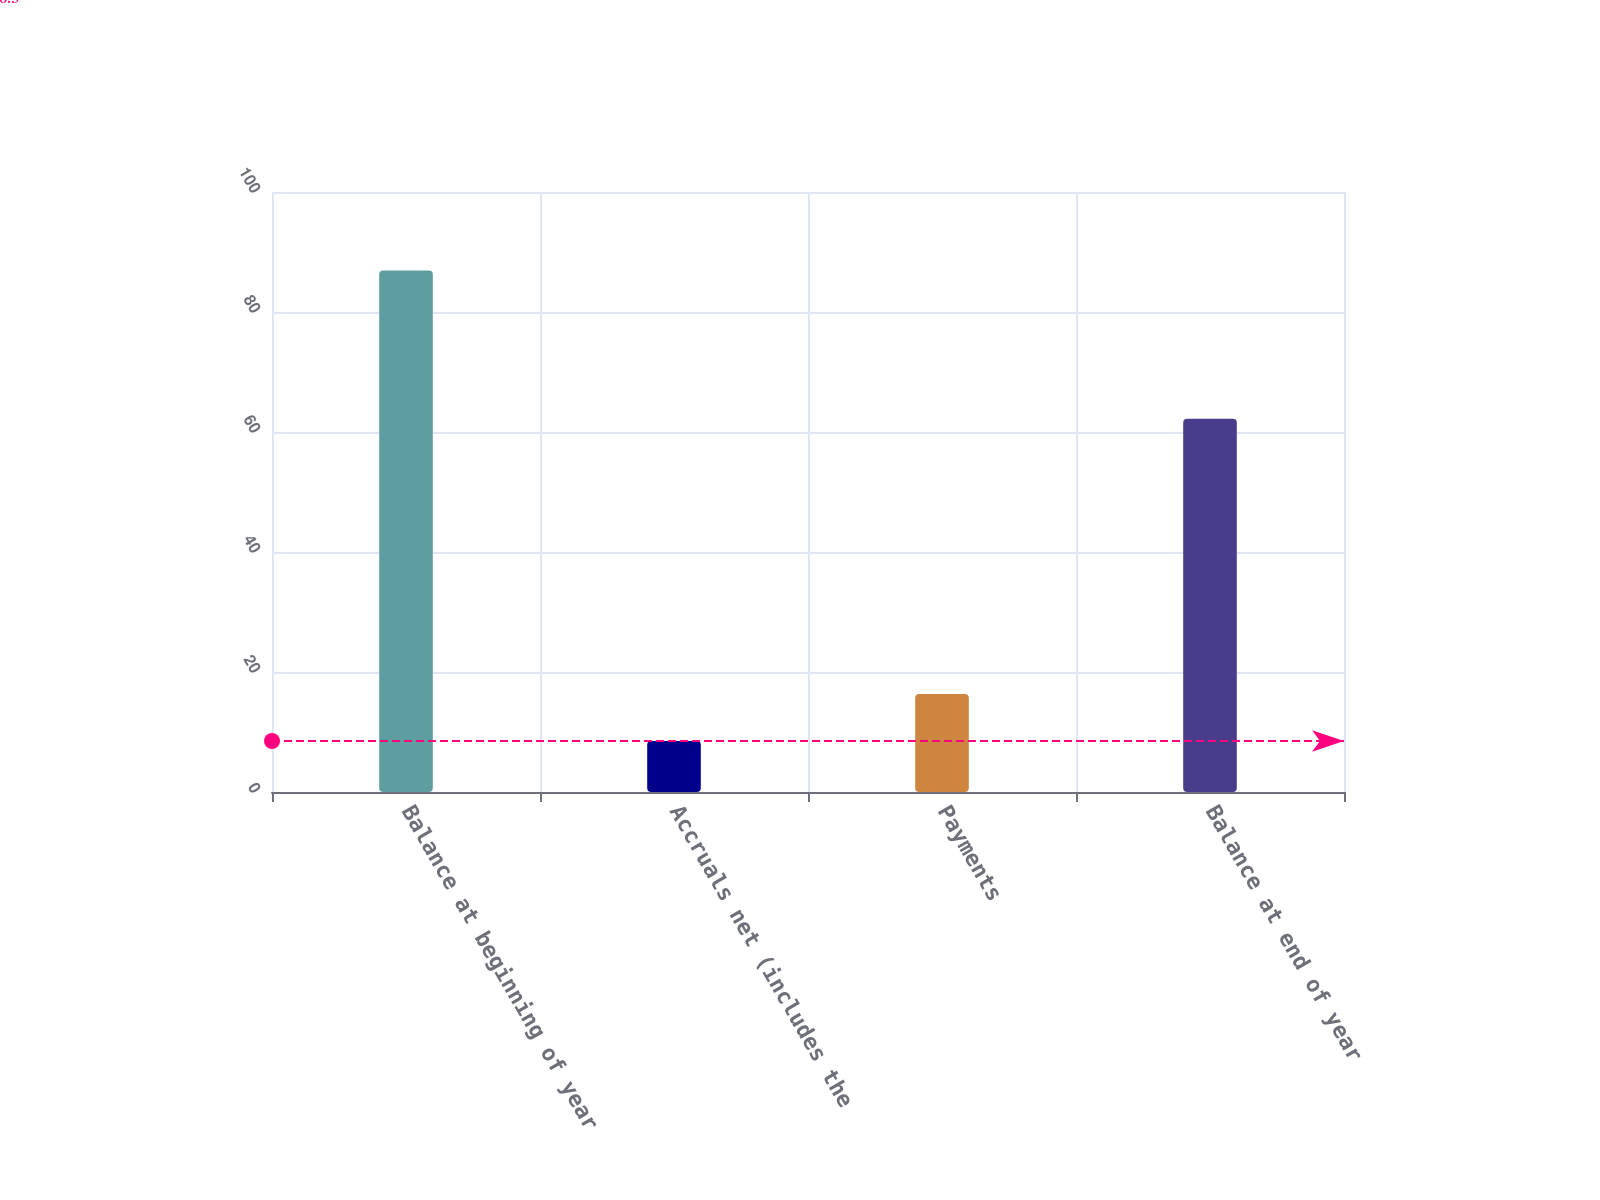Convert chart to OTSL. <chart><loc_0><loc_0><loc_500><loc_500><bar_chart><fcel>Balance at beginning of year<fcel>Accruals net (includes the<fcel>Payments<fcel>Balance at end of year<nl><fcel>86.9<fcel>8.5<fcel>16.34<fcel>62.2<nl></chart> 